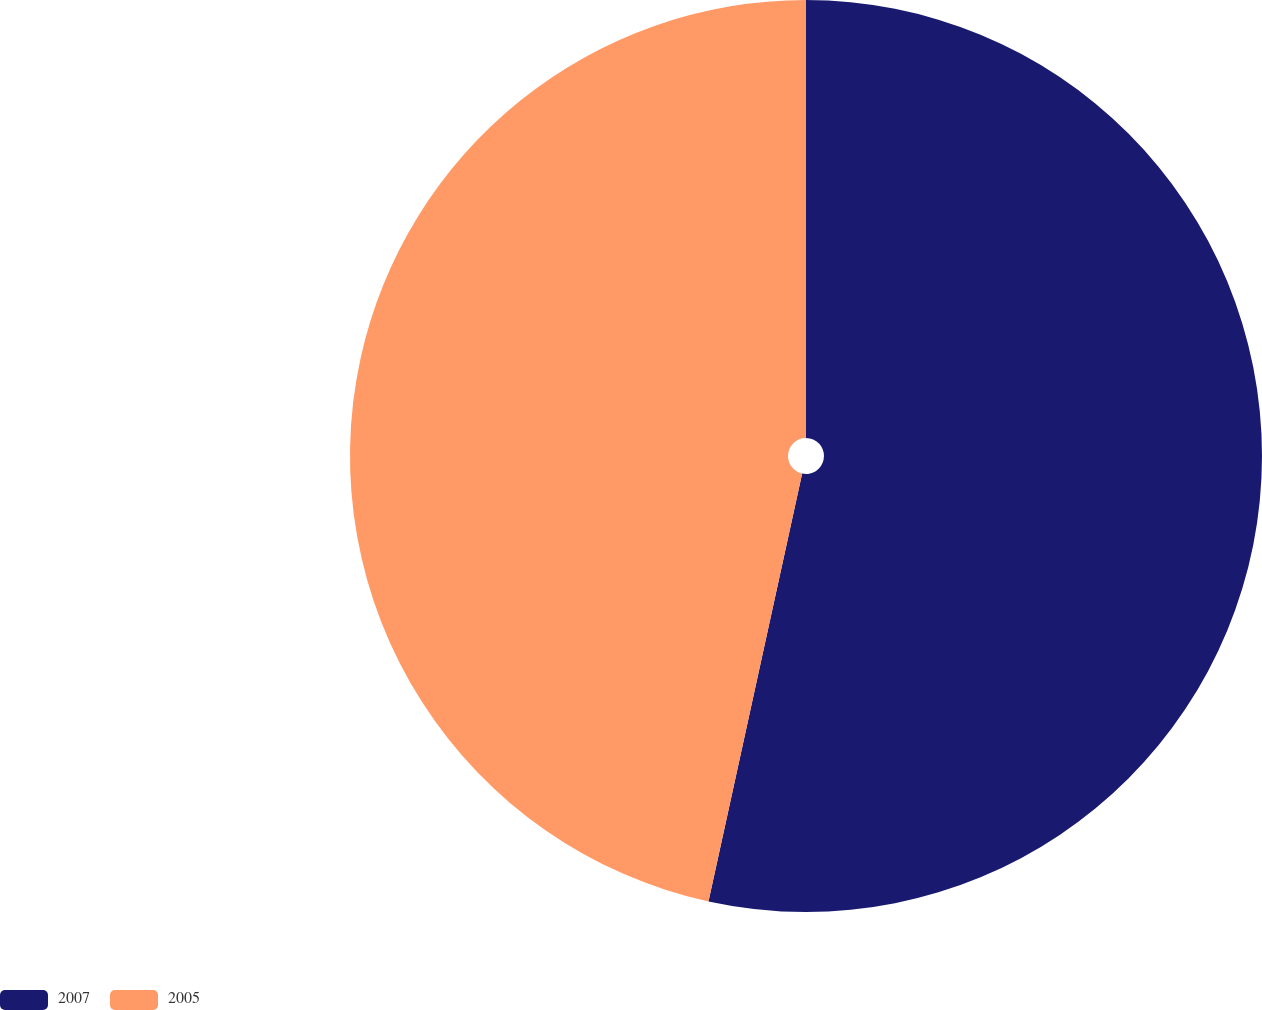<chart> <loc_0><loc_0><loc_500><loc_500><pie_chart><fcel>2007<fcel>2005<nl><fcel>53.43%<fcel>46.57%<nl></chart> 